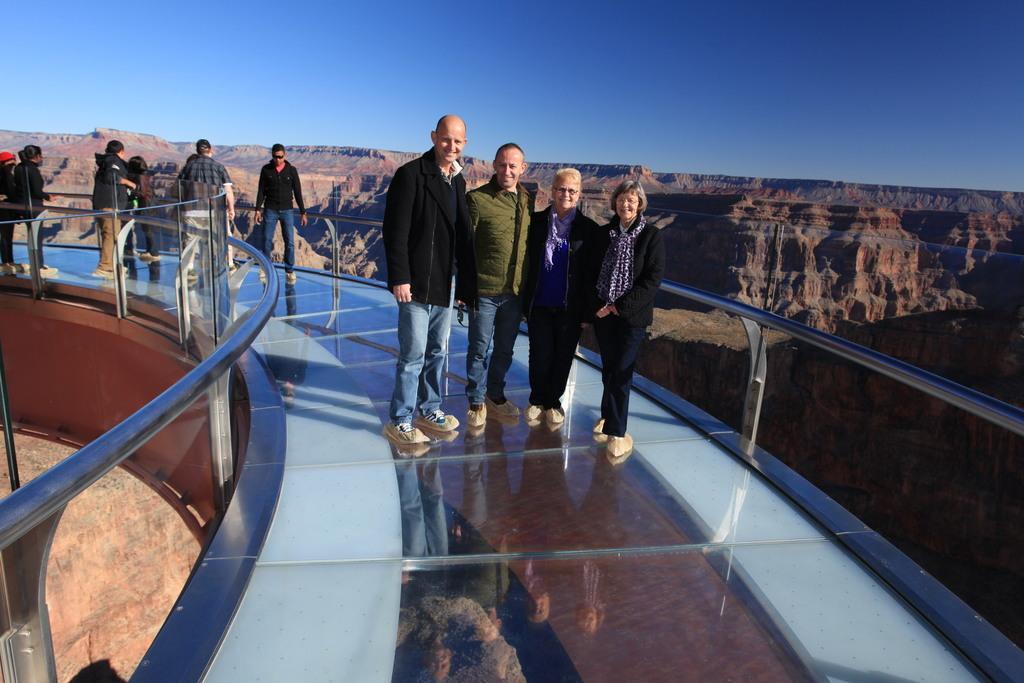In one or two sentences, can you explain what this image depicts? In this picture, we can see a few people on the bridge, we can see poles, rock hill, and the sky. 